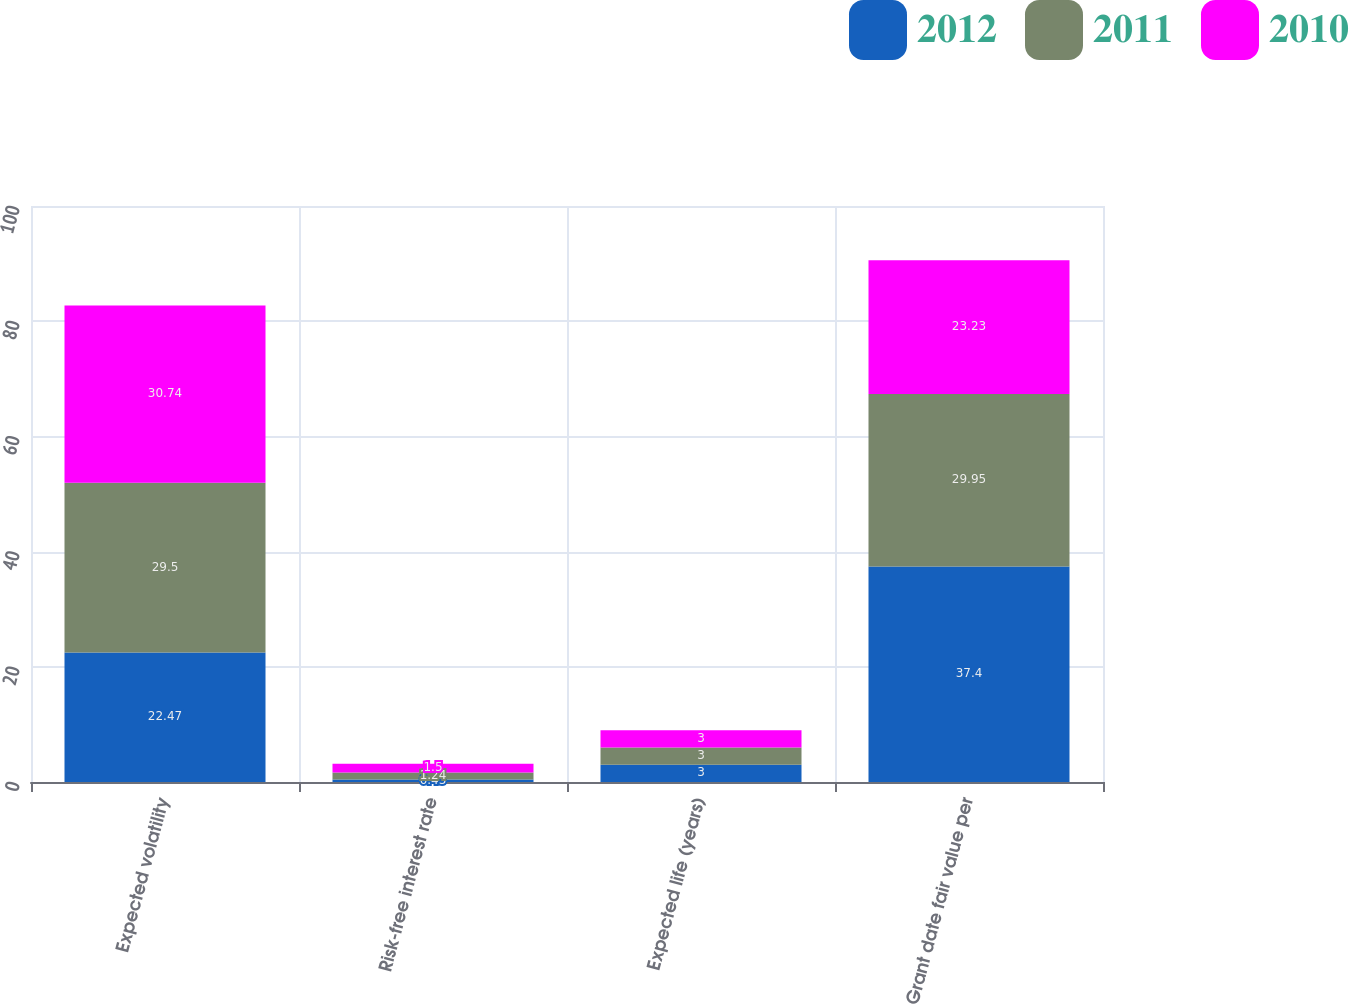<chart> <loc_0><loc_0><loc_500><loc_500><stacked_bar_chart><ecel><fcel>Expected volatility<fcel>Risk-free interest rate<fcel>Expected life (years)<fcel>Grant date fair value per<nl><fcel>2012<fcel>22.47<fcel>0.43<fcel>3<fcel>37.4<nl><fcel>2011<fcel>29.5<fcel>1.24<fcel>3<fcel>29.95<nl><fcel>2010<fcel>30.74<fcel>1.5<fcel>3<fcel>23.23<nl></chart> 